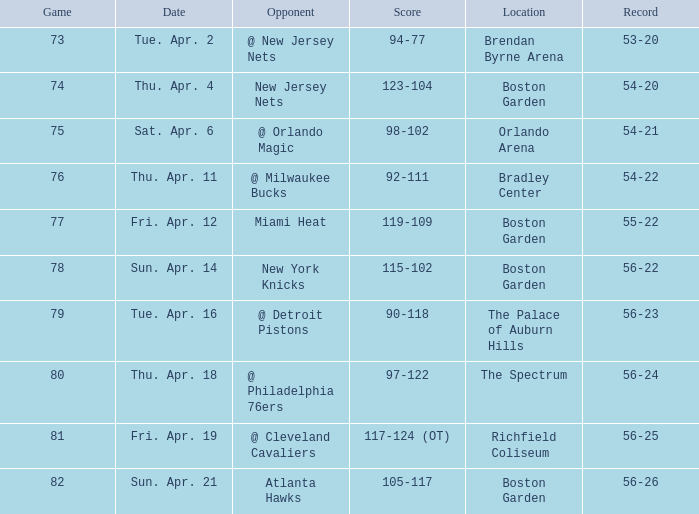Where was game 78 held? Boston Garden. 